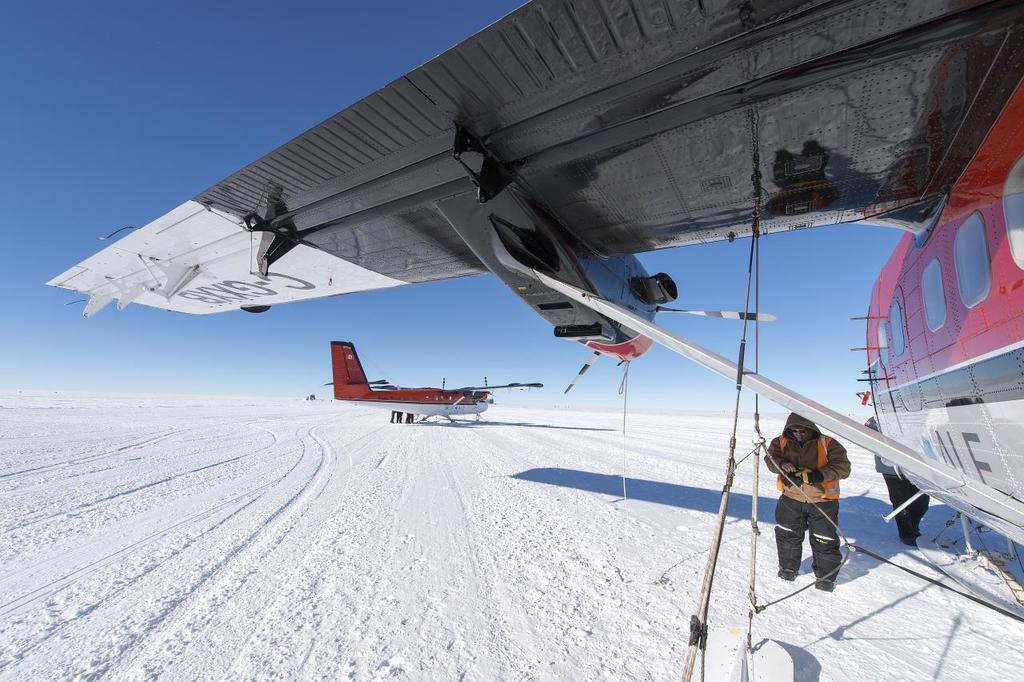Describe this image in one or two sentences. In this picture, there is a plane towards the right. It is in red and white in color. On the top, there is a plane wing. Below it, there is a person wearing a jacket and trousers. In the center, there is another plane. At the bottom, there is a snow. On the top, there is a sky. 